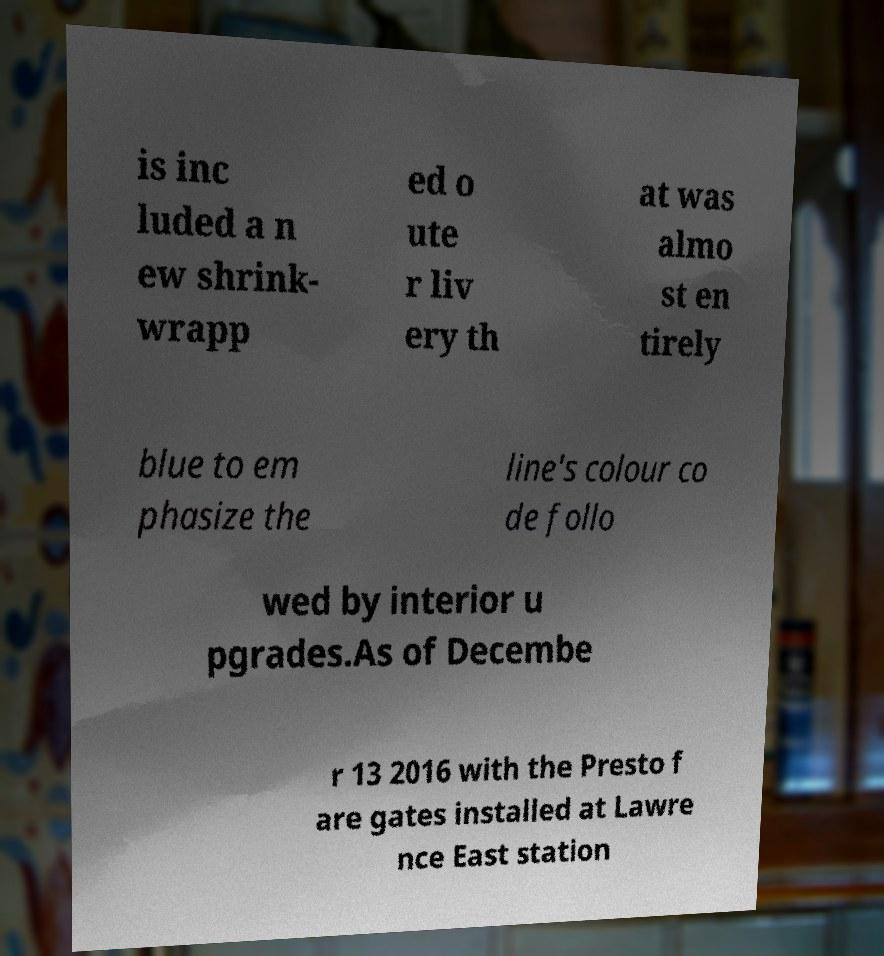Please read and relay the text visible in this image. What does it say? is inc luded a n ew shrink- wrapp ed o ute r liv ery th at was almo st en tirely blue to em phasize the line's colour co de follo wed by interior u pgrades.As of Decembe r 13 2016 with the Presto f are gates installed at Lawre nce East station 